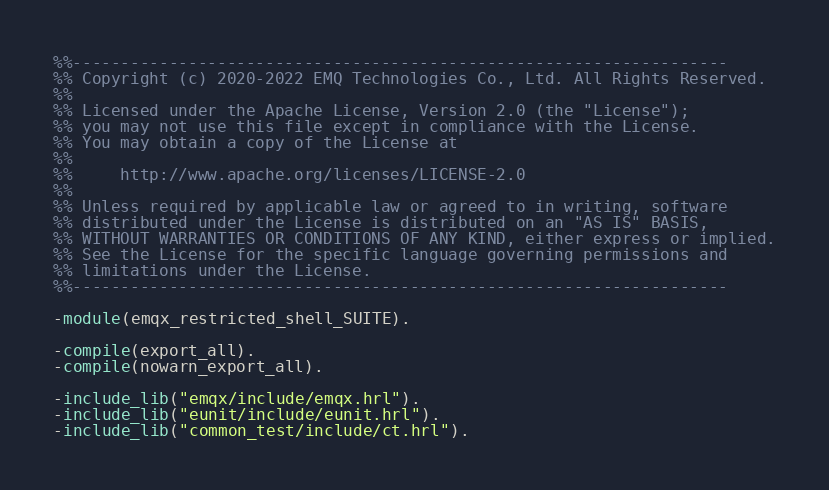<code> <loc_0><loc_0><loc_500><loc_500><_Erlang_>%%--------------------------------------------------------------------
%% Copyright (c) 2020-2022 EMQ Technologies Co., Ltd. All Rights Reserved.
%%
%% Licensed under the Apache License, Version 2.0 (the "License");
%% you may not use this file except in compliance with the License.
%% You may obtain a copy of the License at
%%
%%     http://www.apache.org/licenses/LICENSE-2.0
%%
%% Unless required by applicable law or agreed to in writing, software
%% distributed under the License is distributed on an "AS IS" BASIS,
%% WITHOUT WARRANTIES OR CONDITIONS OF ANY KIND, either express or implied.
%% See the License for the specific language governing permissions and
%% limitations under the License.
%%--------------------------------------------------------------------

-module(emqx_restricted_shell_SUITE).

-compile(export_all).
-compile(nowarn_export_all).

-include_lib("emqx/include/emqx.hrl").
-include_lib("eunit/include/eunit.hrl").
-include_lib("common_test/include/ct.hrl").
</code> 